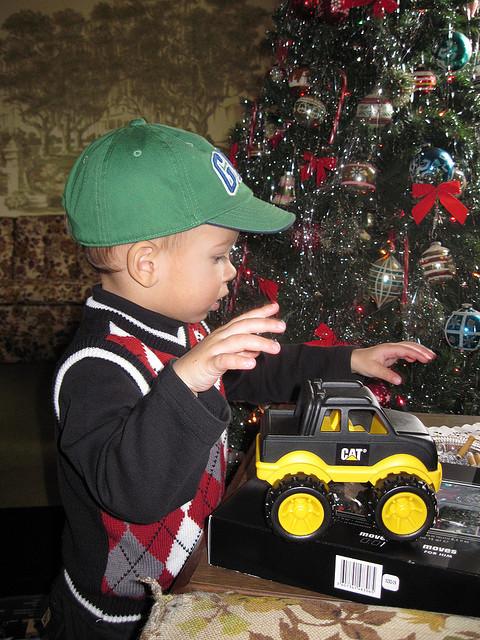What colors are the toy vehicle?
Be succinct. Black and yellow. Could they boy's father have given the boy the truck?
Quick response, please. Yes. Where is the front of the toy vehicle?
Short answer required. Facing right. 